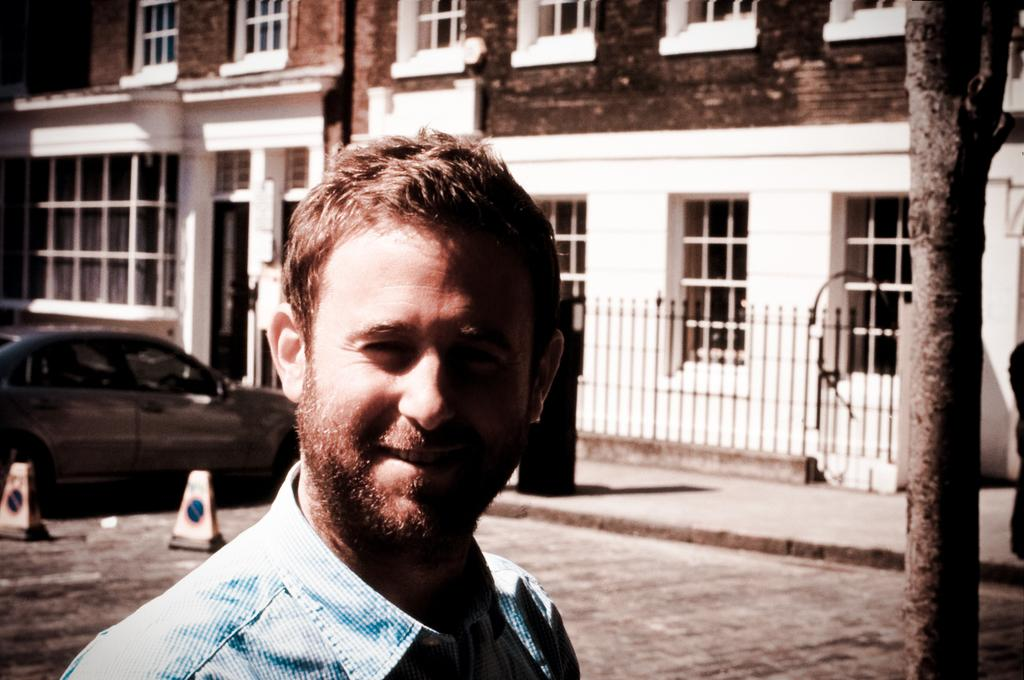Who is present in the image? There is a man in the image. What is the man's facial expression? The man is smiling. What can be seen in the background of the image? There are traffic cones, a car, a building, and a tree in the background of the image. What type of island is visible in the background of the image? There is no island visible in the background of the image. What is the man's level of wealth in the image? The image does not provide any information about the man's wealth. 